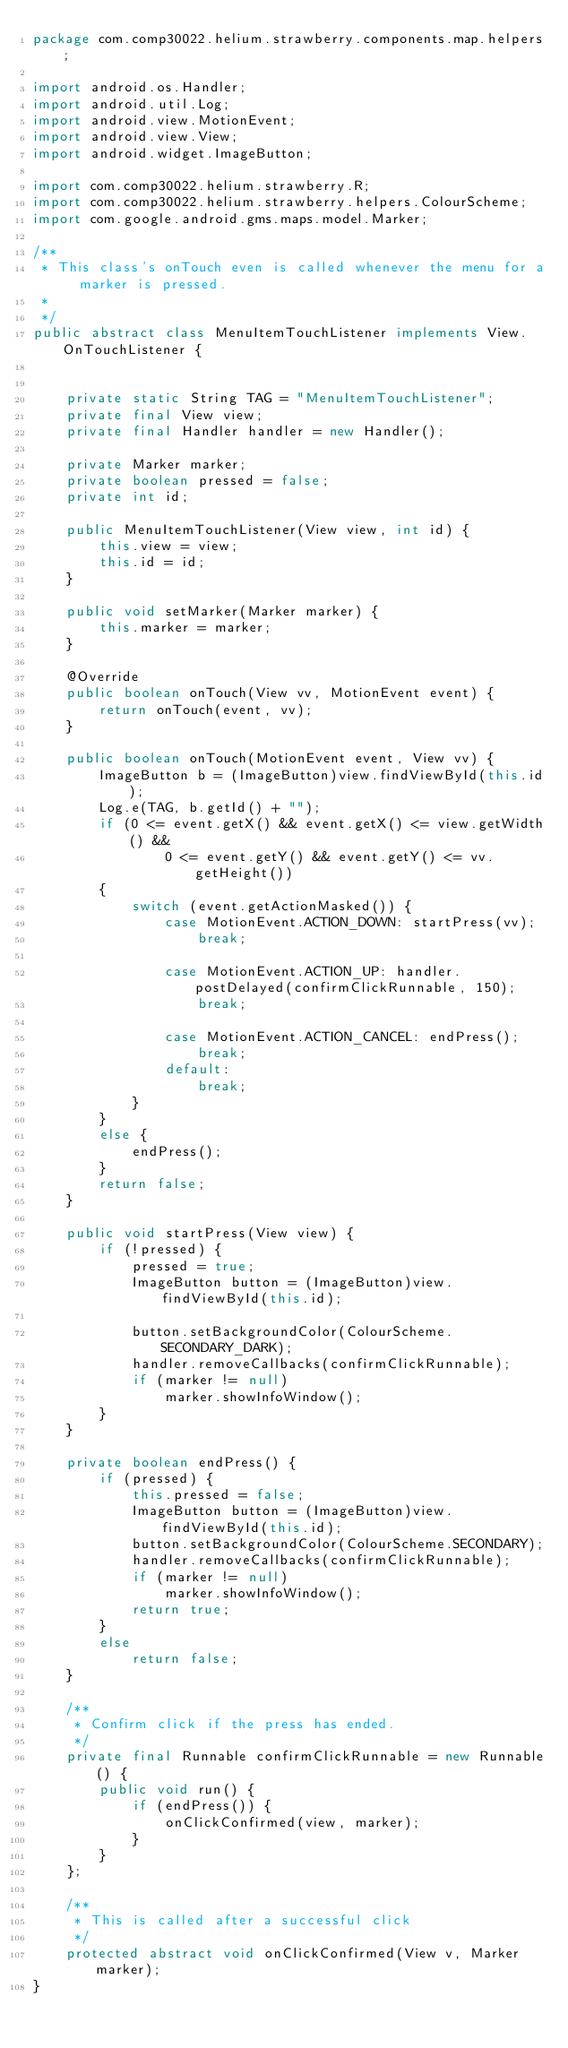Convert code to text. <code><loc_0><loc_0><loc_500><loc_500><_Java_>package com.comp30022.helium.strawberry.components.map.helpers;

import android.os.Handler;
import android.util.Log;
import android.view.MotionEvent;
import android.view.View;
import android.widget.ImageButton;

import com.comp30022.helium.strawberry.R;
import com.comp30022.helium.strawberry.helpers.ColourScheme;
import com.google.android.gms.maps.model.Marker;

/**
 * This class's onTouch even is called whenever the menu for a marker is pressed.
 *
 */
public abstract class MenuItemTouchListener implements View.OnTouchListener {


    private static String TAG = "MenuItemTouchListener";
    private final View view;
    private final Handler handler = new Handler();

    private Marker marker;
    private boolean pressed = false;
    private int id;

    public MenuItemTouchListener(View view, int id) {
        this.view = view;
        this.id = id;
    }

    public void setMarker(Marker marker) {
        this.marker = marker;
    }

    @Override
    public boolean onTouch(View vv, MotionEvent event) {
        return onTouch(event, vv);
    }

    public boolean onTouch(MotionEvent event, View vv) {
        ImageButton b = (ImageButton)view.findViewById(this.id);
        Log.e(TAG, b.getId() + "");
        if (0 <= event.getX() && event.getX() <= view.getWidth() &&
                0 <= event.getY() && event.getY() <= vv.getHeight())
        {
            switch (event.getActionMasked()) {
                case MotionEvent.ACTION_DOWN: startPress(vv);
                    break;

                case MotionEvent.ACTION_UP: handler.postDelayed(confirmClickRunnable, 150);
                    break;

                case MotionEvent.ACTION_CANCEL: endPress();
                    break;
                default:
                    break;
            }
        }
        else {
            endPress();
        }
        return false;
    }

    public void startPress(View view) {
        if (!pressed) {
            pressed = true;
            ImageButton button = (ImageButton)view.findViewById(this.id);

            button.setBackgroundColor(ColourScheme.SECONDARY_DARK);
            handler.removeCallbacks(confirmClickRunnable);
            if (marker != null)
                marker.showInfoWindow();
        }
    }

    private boolean endPress() {
        if (pressed) {
            this.pressed = false;
            ImageButton button = (ImageButton)view.findViewById(this.id);
            button.setBackgroundColor(ColourScheme.SECONDARY);
            handler.removeCallbacks(confirmClickRunnable);
            if (marker != null)
                marker.showInfoWindow();
            return true;
        }
        else
            return false;
    }

    /**
     * Confirm click if the press has ended.
     */
    private final Runnable confirmClickRunnable = new Runnable() {
        public void run() {
            if (endPress()) {
                onClickConfirmed(view, marker);
            }
        }
    };

    /**
     * This is called after a successful click
     */
    protected abstract void onClickConfirmed(View v, Marker marker);
}
</code> 